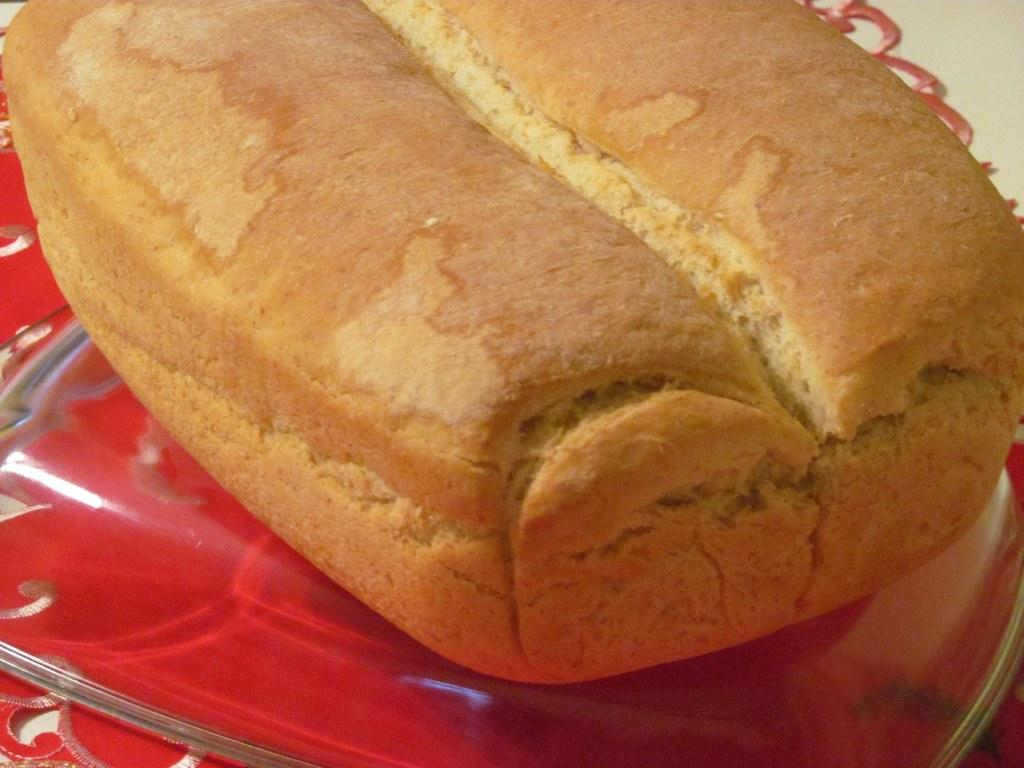What type of food is visible in the image? There is a bread in the image. What color is the surface on which the bread is placed? The bread is on a red surface. Is there a baby playing with the bread in the image? There is no baby present in the image, and the bread is not being played with. 